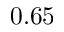<formula> <loc_0><loc_0><loc_500><loc_500>0 . 6 5</formula> 